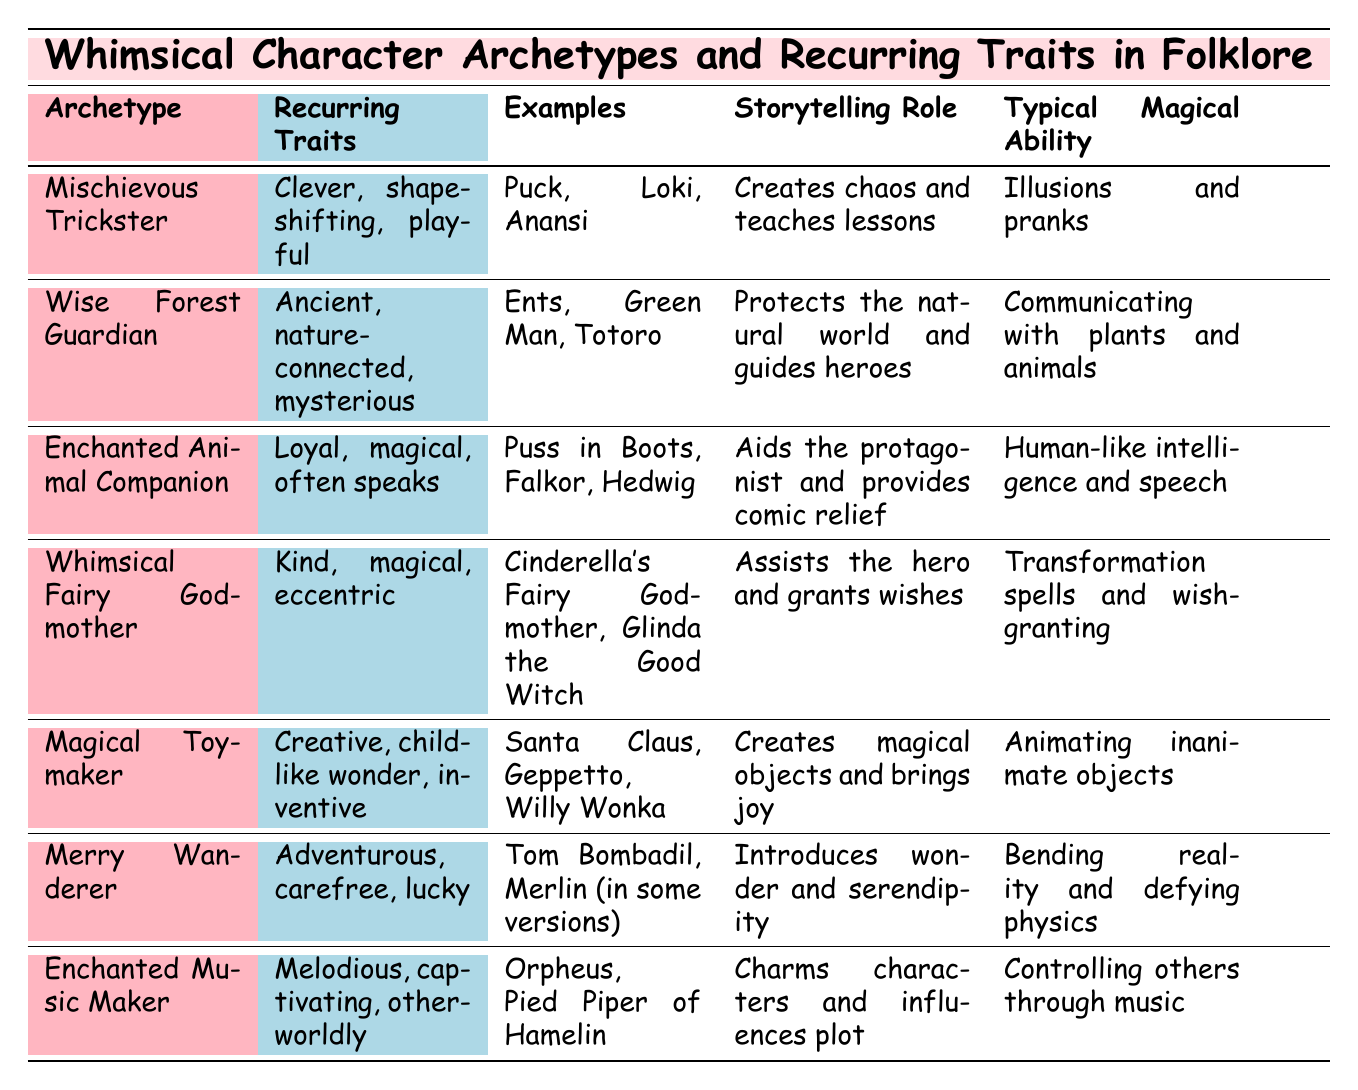What is the typical magical ability of the Merry Wanderer archetype? According to the table, the typical magical ability associated with the Merry Wanderer is "Bending reality and defying physics."
Answer: Bending reality and defying physics Which archetype is known for being ancient, nature-connected, and mysterious? The table lists the Wise Forest Guardian as the archetype described by those traits.
Answer: Wise Forest Guardian Are there any archetypes that provide comic relief? Yes, the Enchanted Animal Companion archetype is noted for aiding the protagonist and providing comic relief.
Answer: Yes List the examples of the Mischievous Trickster archetype. The table specifies that the examples of the Mischievous Trickster archetype include Puck, Loki, and Anansi.
Answer: Puck, Loki, Anansi Which character archetype creates chaos and teaches lessons? The table identifies the Mischievous Trickster as the character archetype that creates chaos and teaches lessons.
Answer: Mischievous Trickster How many archetypes have a storytelling role related to guiding heroes? The Wise Forest Guardian is the only archetype listed in the table that has a storytelling role related to guiding heroes.
Answer: 1 Is there any archetype that includes Santa Claus as an example? Yes, the Magical Toymaker archetype includes Santa Claus as one of its examples.
Answer: Yes What traits are common in the Whimsical Fairy Godmother archetype? The table outlines that the recurring traits of the Whimsical Fairy Godmother include being kind, magical, and eccentric.
Answer: Kind, magical, eccentric Compare the storytelling roles of the Enchanted Music Maker and the Magical Toymaker archetypes. The Enchanted Music Maker charms characters and influences the plot, while the Magical Toymaker creates magical objects and brings joy. Both contribute to the story in different ways: one through music and the other through creativity and invention.
Answer: Different roles: one charms through music, the other creates joy with magic Which archetype is described as having the magical ability of animating inanimate objects? The table lists the Magical Toymaker archetype as having the ability to animate inanimate objects.
Answer: Magical Toymaker 